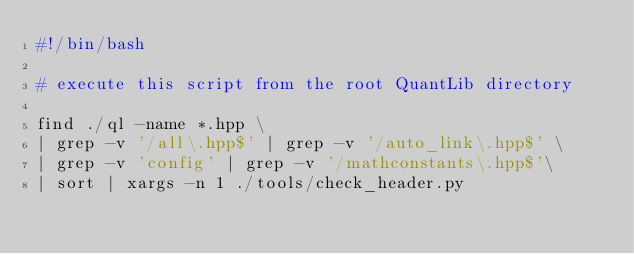Convert code to text. <code><loc_0><loc_0><loc_500><loc_500><_Bash_>#!/bin/bash

# execute this script from the root QuantLib directory

find ./ql -name *.hpp \
| grep -v '/all\.hpp$' | grep -v '/auto_link\.hpp$' \
| grep -v 'config' | grep -v '/mathconstants\.hpp$'\
| sort | xargs -n 1 ./tools/check_header.py

</code> 